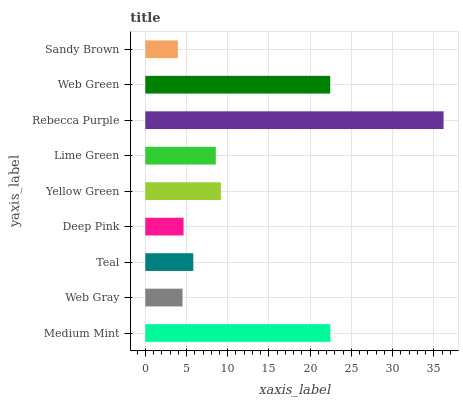Is Sandy Brown the minimum?
Answer yes or no. Yes. Is Rebecca Purple the maximum?
Answer yes or no. Yes. Is Web Gray the minimum?
Answer yes or no. No. Is Web Gray the maximum?
Answer yes or no. No. Is Medium Mint greater than Web Gray?
Answer yes or no. Yes. Is Web Gray less than Medium Mint?
Answer yes or no. Yes. Is Web Gray greater than Medium Mint?
Answer yes or no. No. Is Medium Mint less than Web Gray?
Answer yes or no. No. Is Lime Green the high median?
Answer yes or no. Yes. Is Lime Green the low median?
Answer yes or no. Yes. Is Rebecca Purple the high median?
Answer yes or no. No. Is Medium Mint the low median?
Answer yes or no. No. 